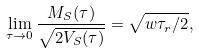<formula> <loc_0><loc_0><loc_500><loc_500>\lim _ { \tau \rightarrow 0 } \frac { M _ { S } ( \tau ) } { \sqrt { 2 V _ { S } ( \tau ) } } = \sqrt { { w \tau _ { r } } / { 2 } } ,</formula> 